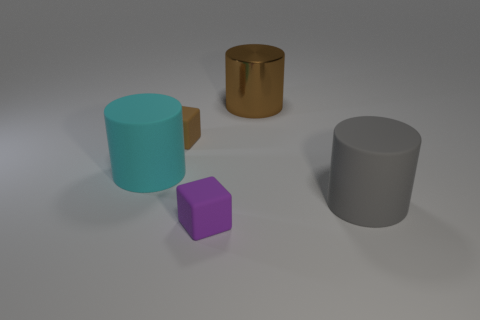Subtract all shiny cylinders. How many cylinders are left? 2 Add 4 brown shiny things. How many objects exist? 9 Subtract all cubes. How many objects are left? 3 Subtract 0 yellow cubes. How many objects are left? 5 Subtract all large gray things. Subtract all small rubber things. How many objects are left? 2 Add 4 large brown metal things. How many large brown metal things are left? 5 Add 3 brown metal things. How many brown metal things exist? 4 